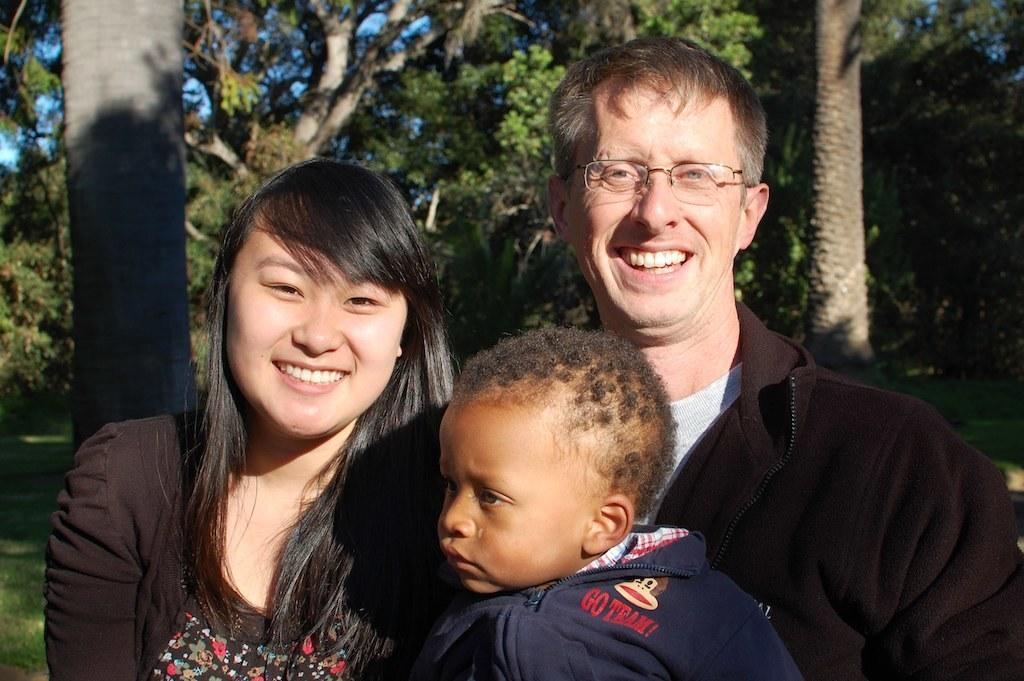How many people are present in the image? There are three people in the image: a man, a woman, and a boy. What are the expressions of the people in the image? Both the man and woman are smiling in the image. What can be seen in the background of the image? There are trees in the background of the image. What type of honey is being used by the boy in the image? There is no honey present in the image, and the boy is not using any honey. What organization is the boy representing in the image? There is no indication of any organization in the image, and the boy is not representing any organization. 